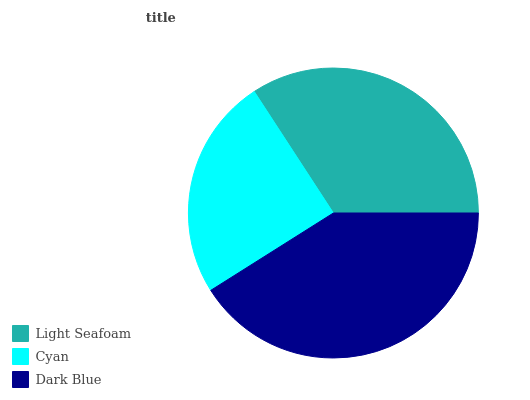Is Cyan the minimum?
Answer yes or no. Yes. Is Dark Blue the maximum?
Answer yes or no. Yes. Is Dark Blue the minimum?
Answer yes or no. No. Is Cyan the maximum?
Answer yes or no. No. Is Dark Blue greater than Cyan?
Answer yes or no. Yes. Is Cyan less than Dark Blue?
Answer yes or no. Yes. Is Cyan greater than Dark Blue?
Answer yes or no. No. Is Dark Blue less than Cyan?
Answer yes or no. No. Is Light Seafoam the high median?
Answer yes or no. Yes. Is Light Seafoam the low median?
Answer yes or no. Yes. Is Cyan the high median?
Answer yes or no. No. Is Dark Blue the low median?
Answer yes or no. No. 